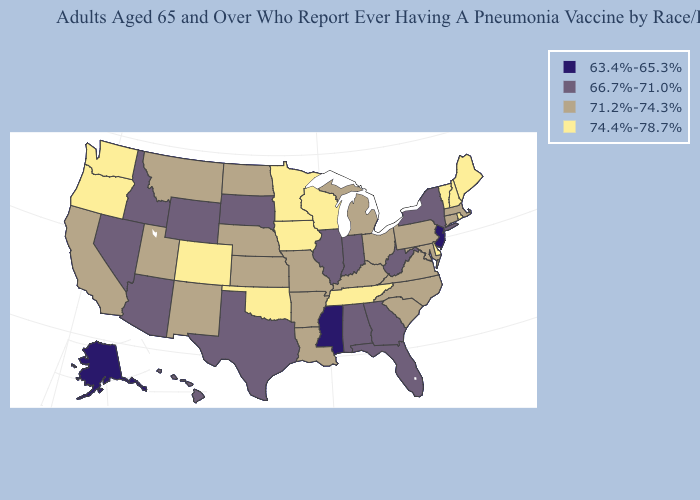Name the states that have a value in the range 63.4%-65.3%?
Concise answer only. Alaska, Mississippi, New Jersey. What is the lowest value in states that border Kentucky?
Be succinct. 66.7%-71.0%. Name the states that have a value in the range 66.7%-71.0%?
Keep it brief. Alabama, Arizona, Florida, Georgia, Hawaii, Idaho, Illinois, Indiana, Nevada, New York, South Dakota, Texas, West Virginia, Wyoming. Does Colorado have the same value as Washington?
Concise answer only. Yes. Name the states that have a value in the range 63.4%-65.3%?
Keep it brief. Alaska, Mississippi, New Jersey. What is the value of Hawaii?
Concise answer only. 66.7%-71.0%. Does the first symbol in the legend represent the smallest category?
Give a very brief answer. Yes. Name the states that have a value in the range 66.7%-71.0%?
Concise answer only. Alabama, Arizona, Florida, Georgia, Hawaii, Idaho, Illinois, Indiana, Nevada, New York, South Dakota, Texas, West Virginia, Wyoming. Which states have the highest value in the USA?
Give a very brief answer. Colorado, Delaware, Iowa, Maine, Minnesota, New Hampshire, Oklahoma, Oregon, Rhode Island, Tennessee, Vermont, Washington, Wisconsin. What is the value of Missouri?
Give a very brief answer. 71.2%-74.3%. Does Mississippi have the lowest value in the South?
Write a very short answer. Yes. Is the legend a continuous bar?
Answer briefly. No. Among the states that border North Dakota , does South Dakota have the lowest value?
Give a very brief answer. Yes. What is the highest value in states that border Georgia?
Concise answer only. 74.4%-78.7%. What is the value of Pennsylvania?
Quick response, please. 71.2%-74.3%. 